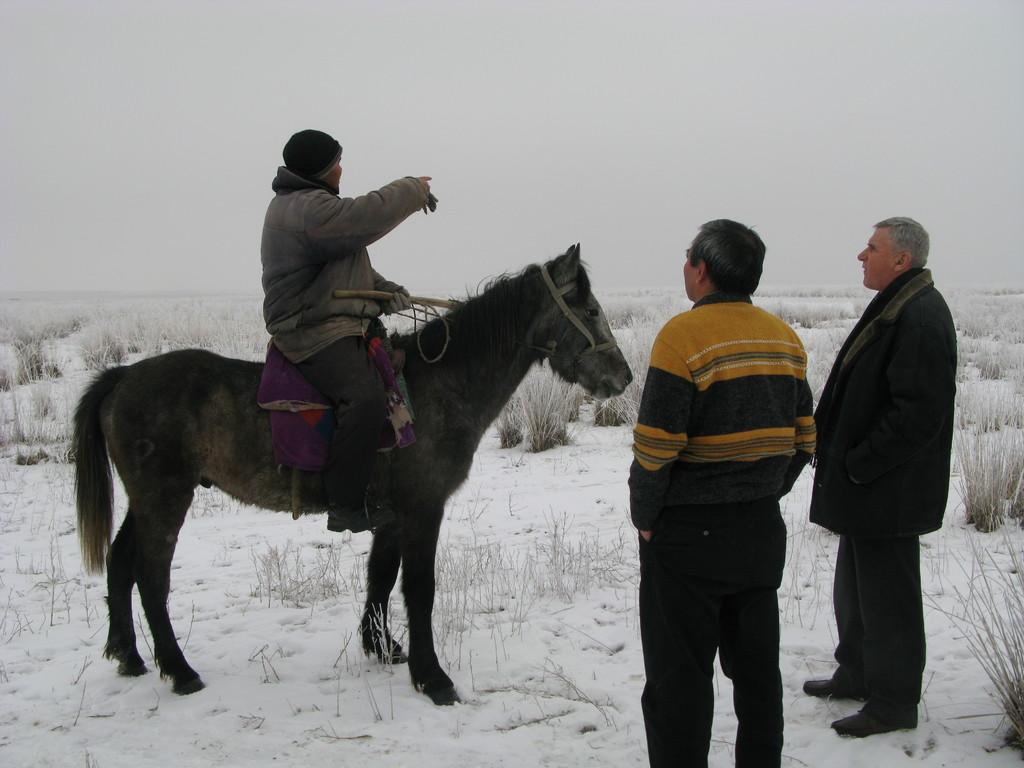How many people are in the image? There are three men in the image. What is one man doing in the image? One man is riding a horse. What are the other two men doing in the image? The other two men are standing. What type of fog can be seen around the horse's fang in the image? There is no fog or fang present in the image; it features three men, one of whom is riding a horse. 